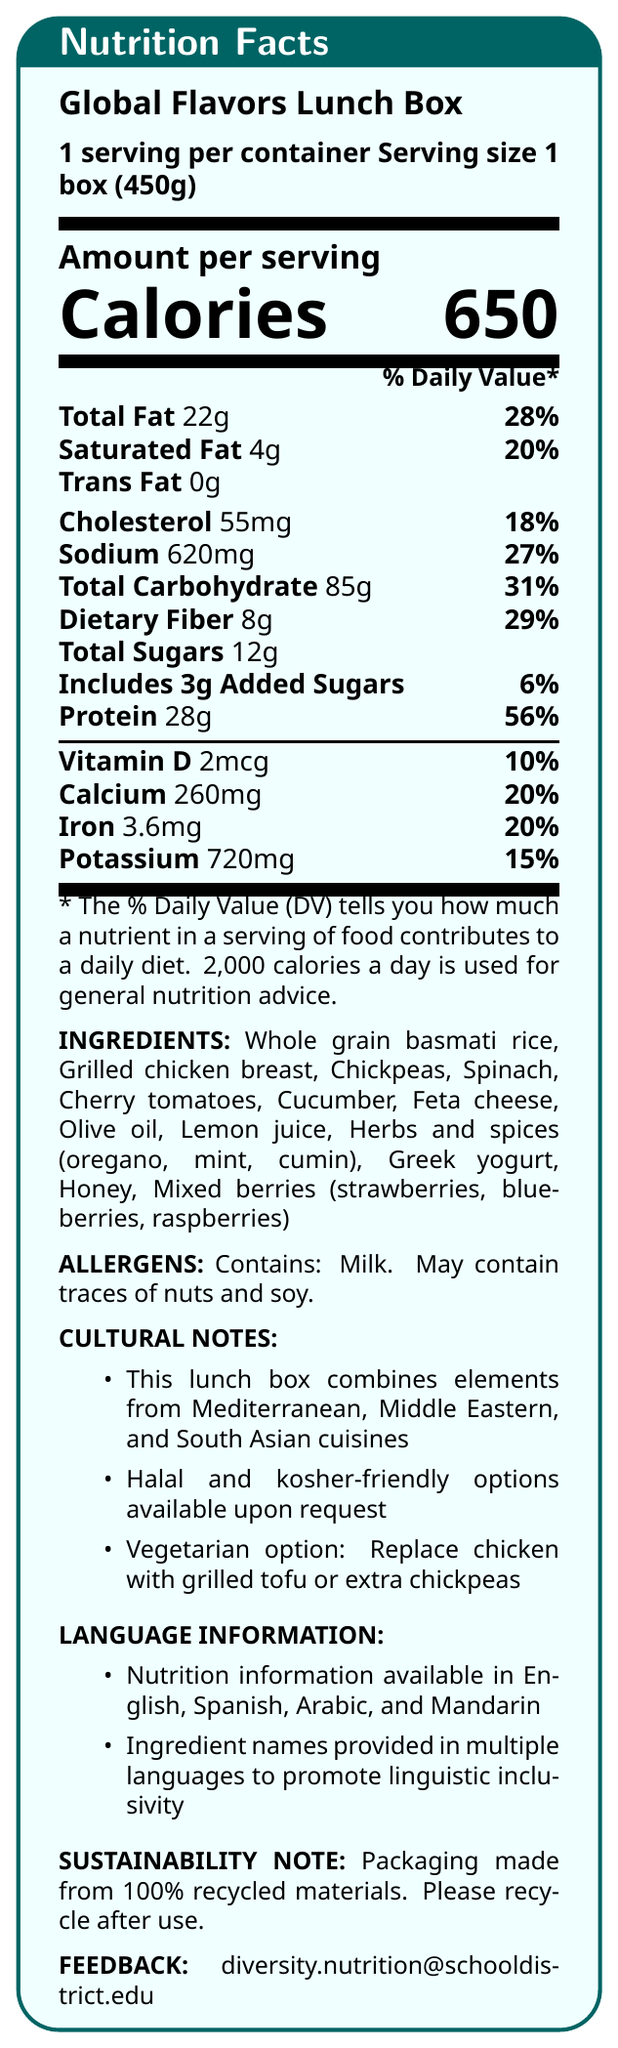What is the serving size for the Global Flavors Lunch Box? The serving size is stated as "1 box (450g)" at the top of the document.
Answer: 1 box (450g) How many calories are in one serving of the Global Flavors Lunch Box? The number of calories per serving is prominently displayed as 650 in the document.
Answer: 650 What is the main protein ingredient in the Global Flavors Lunch Box? The ingredients list specifies "Grilled chicken breast" as one of the main items.
Answer: Grilled chicken breast What percentage of the daily value for dietary fiber is in one serving? The document lists 8g of dietary fiber per serving, which is 29% of the daily value.
Answer: 29% Which allergen is specifically mentioned as being contained in the lunch box? The allergens section mentions "Contains: Milk."
Answer: Milk What cuisines are combined in the Global Flavors Lunch Box? (Choose all that apply) A. Mediterranean B. Middle Eastern C. South Asian D. Mexican E. Italian The cultural notes mention that the lunch box combines elements from Mediterranean, Middle Eastern, and South Asian cuisines.
Answer: A, B, C Which vitamin is present in the lunch box in the amount of 2mcg? A. Vitamin A B. Vitamin B6 C. Vitamin D D. Vitamin E The vitamins section reports 2mcg of Vitamin D.
Answer: C Is this lunch box suitable for vegetarians in its standard form? The standard form includes grilled chicken breast, which is not vegetarian. However, there is a noted vegetarian option by replacing chicken with grilled tofu or extra chickpeas.
Answer: No Summarize the key nutritional and cultural aspects of the Global Flavors Lunch Box. The document provides detailed nutritional information, cultural notes emphasizing inclusivity, and notes on sustainability. It highlights the variety in cuisine and offers options to cater to different dietary preferences and restrictions.
Answer: The Global Flavors Lunch Box contains 650 calories per serving, with notable contents like 28g protein, 85g carbohydrates, and 22g total fat. It combines Mediterranean, Middle Eastern, and South Asian cuisines, and offers halal, kosher, and vegetarian-friendly options. Nutritional information is available in multiple languages, and the packaging is made from recycled materials. The ingredients include whole grain basmati rice, grilled chicken, various vegetables, feta cheese, and mixed berries. It contains milk and may contain traces of nuts and soy. What is the email address for providing feedback about the lunch box? The feedback section lists the email address for providing feedback.
Answer: diversity.nutrition@schooldistrict.edu How many grams of total sugars are in the Global Flavors Lunch Box? The nutrition facts list 12g of total sugars per serving.
Answer: 12g Does the document state that the lunch box is vegan? The document does not state that the lunch box is vegan. It contains ingredients like grilled chicken and Greek yogurt which are not vegan, though it offers a vegetarian option.
Answer: No What are two ways to make the lunch box kosher-friendly? The cultural notes mention that halal and kosher-friendly options are available upon request.
Answer: Halal options, Specific dietary requests Can the exact sodium content per serving help us understand the total daily sodium intake for a child? While the sodium content per serving is listed as 620mg, total daily sodium intake would require knowing the child's overall diet for the day, which is not provided.
Answer: No, Not enough information 